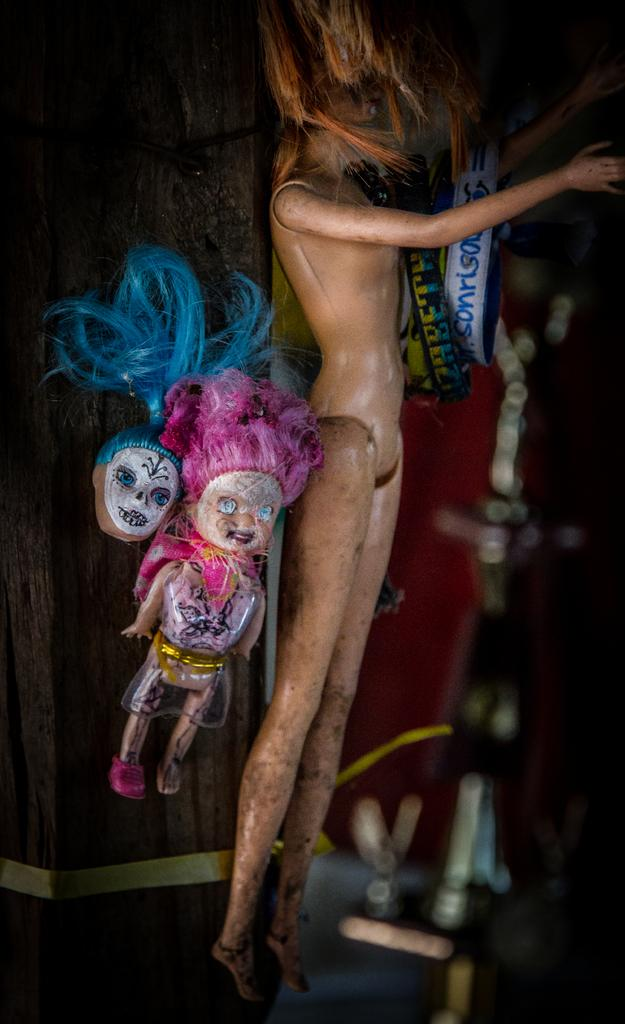What is located in the center of the image? There are toys and banners in the center of the image. What can be seen in the background of the image? There is a wall and other objects visible in the background of the image. Can you tell me the grade of the airplane visible in the image? There is no airplane present in the image, so it is not possible to determine its grade. What type of sofa can be seen in the image? There is no sofa present in the image. 